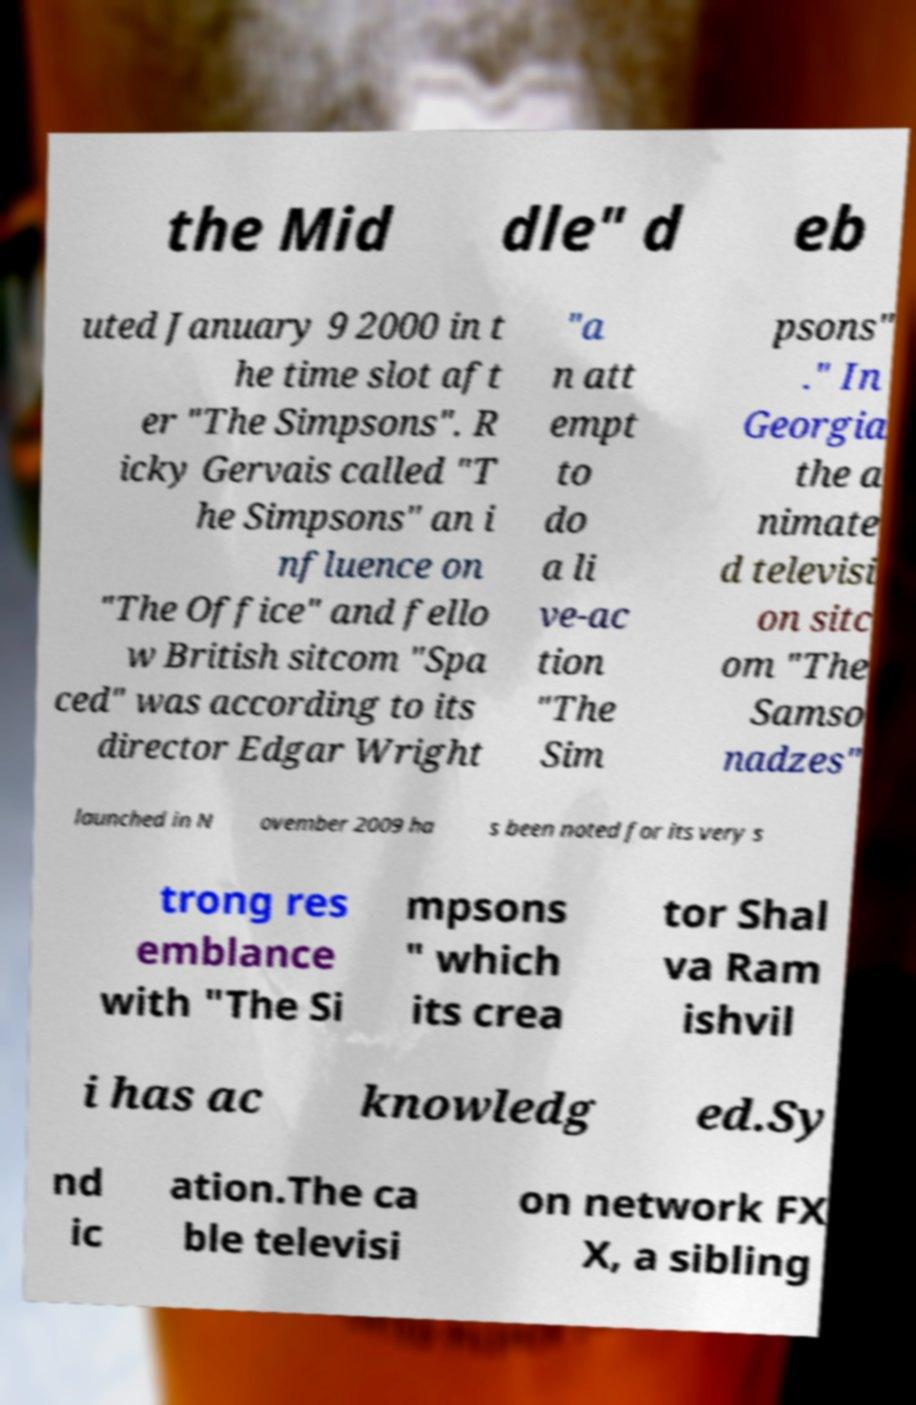Could you assist in decoding the text presented in this image and type it out clearly? the Mid dle" d eb uted January 9 2000 in t he time slot aft er "The Simpsons". R icky Gervais called "T he Simpsons" an i nfluence on "The Office" and fello w British sitcom "Spa ced" was according to its director Edgar Wright "a n att empt to do a li ve-ac tion "The Sim psons" ." In Georgia the a nimate d televisi on sitc om "The Samso nadzes" launched in N ovember 2009 ha s been noted for its very s trong res emblance with "The Si mpsons " which its crea tor Shal va Ram ishvil i has ac knowledg ed.Sy nd ic ation.The ca ble televisi on network FX X, a sibling 